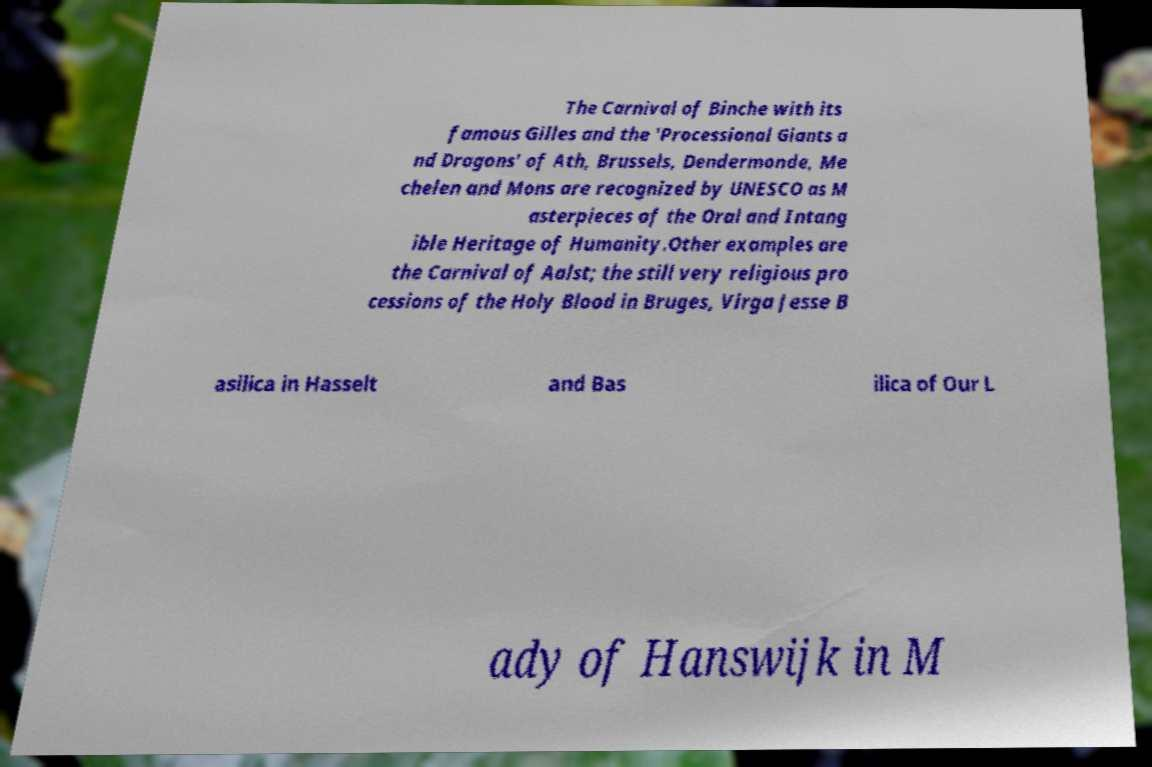Please identify and transcribe the text found in this image. The Carnival of Binche with its famous Gilles and the 'Processional Giants a nd Dragons' of Ath, Brussels, Dendermonde, Me chelen and Mons are recognized by UNESCO as M asterpieces of the Oral and Intang ible Heritage of Humanity.Other examples are the Carnival of Aalst; the still very religious pro cessions of the Holy Blood in Bruges, Virga Jesse B asilica in Hasselt and Bas ilica of Our L ady of Hanswijk in M 